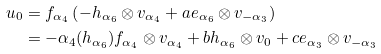Convert formula to latex. <formula><loc_0><loc_0><loc_500><loc_500>u _ { 0 } & = f _ { \alpha _ { 4 } } \left ( - h _ { \alpha _ { 6 } } \otimes v _ { \alpha _ { 4 } } + a e _ { \alpha _ { 6 } } \otimes v _ { - \alpha _ { 3 } } \right ) \\ & = - \alpha _ { 4 } ( h _ { \alpha _ { 6 } } ) f _ { \alpha _ { 4 } } \otimes v _ { \alpha _ { 4 } } + b h _ { \alpha _ { 6 } } \otimes v _ { 0 } + c e _ { \alpha _ { 3 } } \otimes v _ { - \alpha _ { 3 } }</formula> 